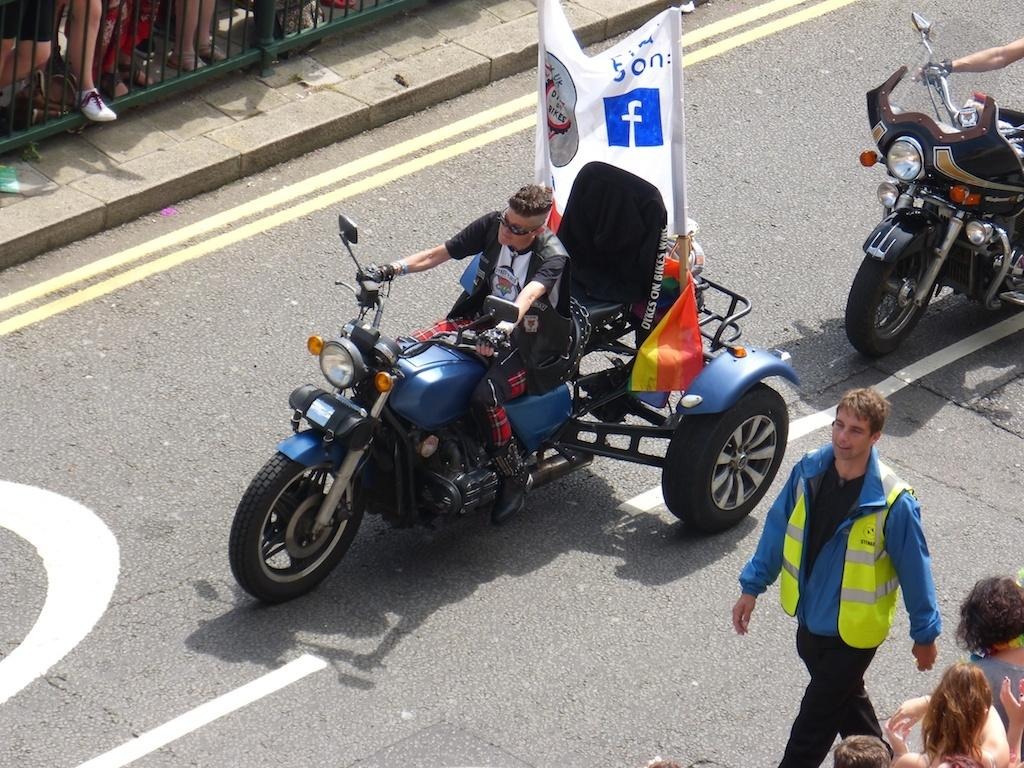What can be seen in the foreground of the picture? There are vehicles and people in the foreground of the picture. What type of path is visible in the foreground? There is a road in the foreground of the picture. What is located in the top left corner of the picture? There is a footpath, railing, and people in the top left corner of the picture. Can you tell me how many wheels are on the bee in the picture? There is no bee present in the picture, and therefore no wheels can be counted on a bee. 